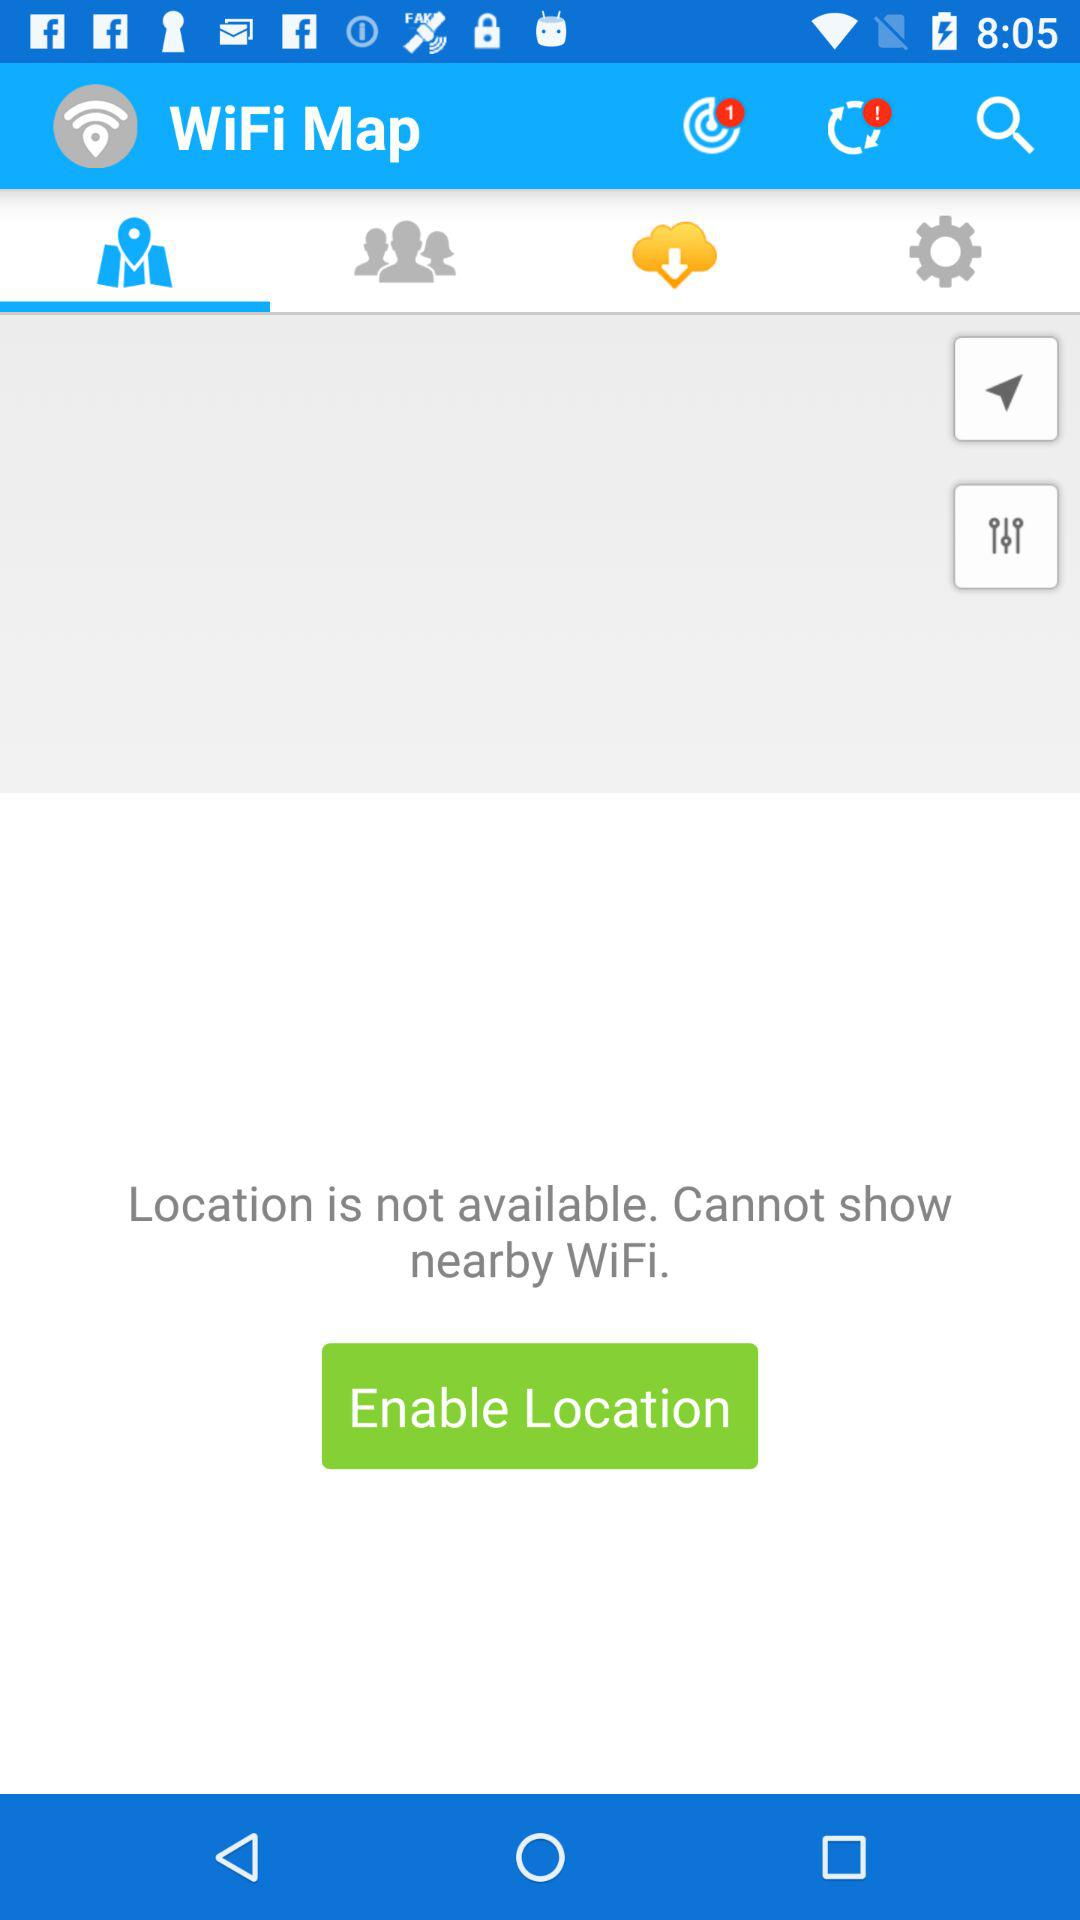What is the name of the application? The name of the application is "WiFi Map". 